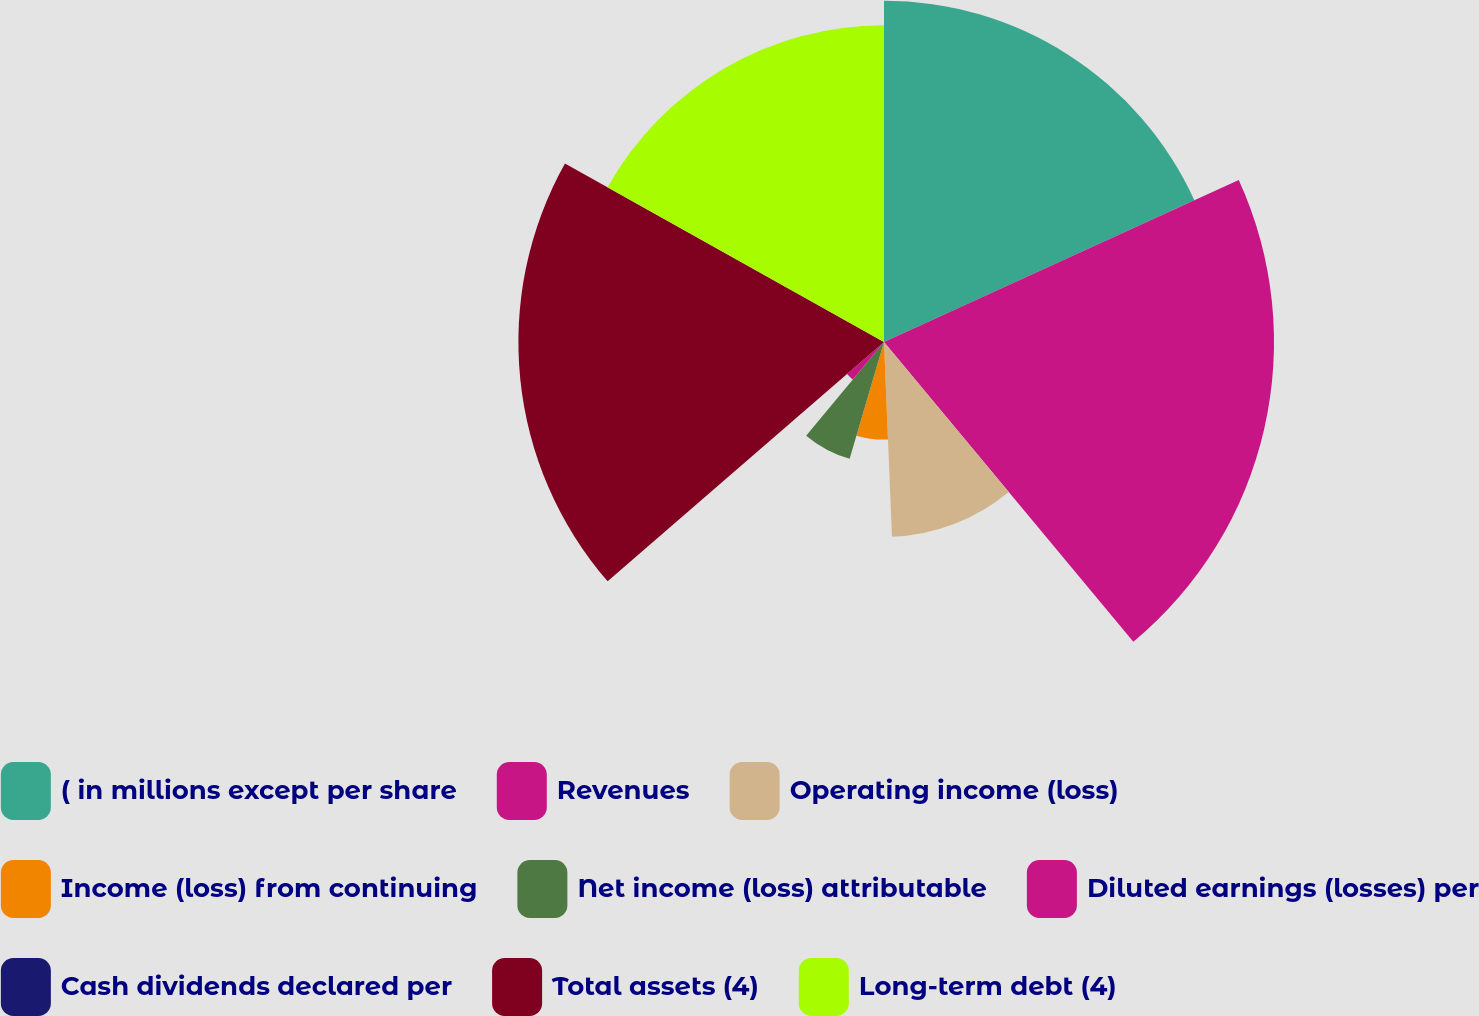Convert chart. <chart><loc_0><loc_0><loc_500><loc_500><pie_chart><fcel>( in millions except per share<fcel>Revenues<fcel>Operating income (loss)<fcel>Income (loss) from continuing<fcel>Net income (loss) attributable<fcel>Diluted earnings (losses) per<fcel>Cash dividends declared per<fcel>Total assets (4)<fcel>Long-term debt (4)<nl><fcel>18.18%<fcel>20.78%<fcel>10.39%<fcel>5.2%<fcel>6.49%<fcel>2.6%<fcel>0.0%<fcel>19.48%<fcel>16.88%<nl></chart> 